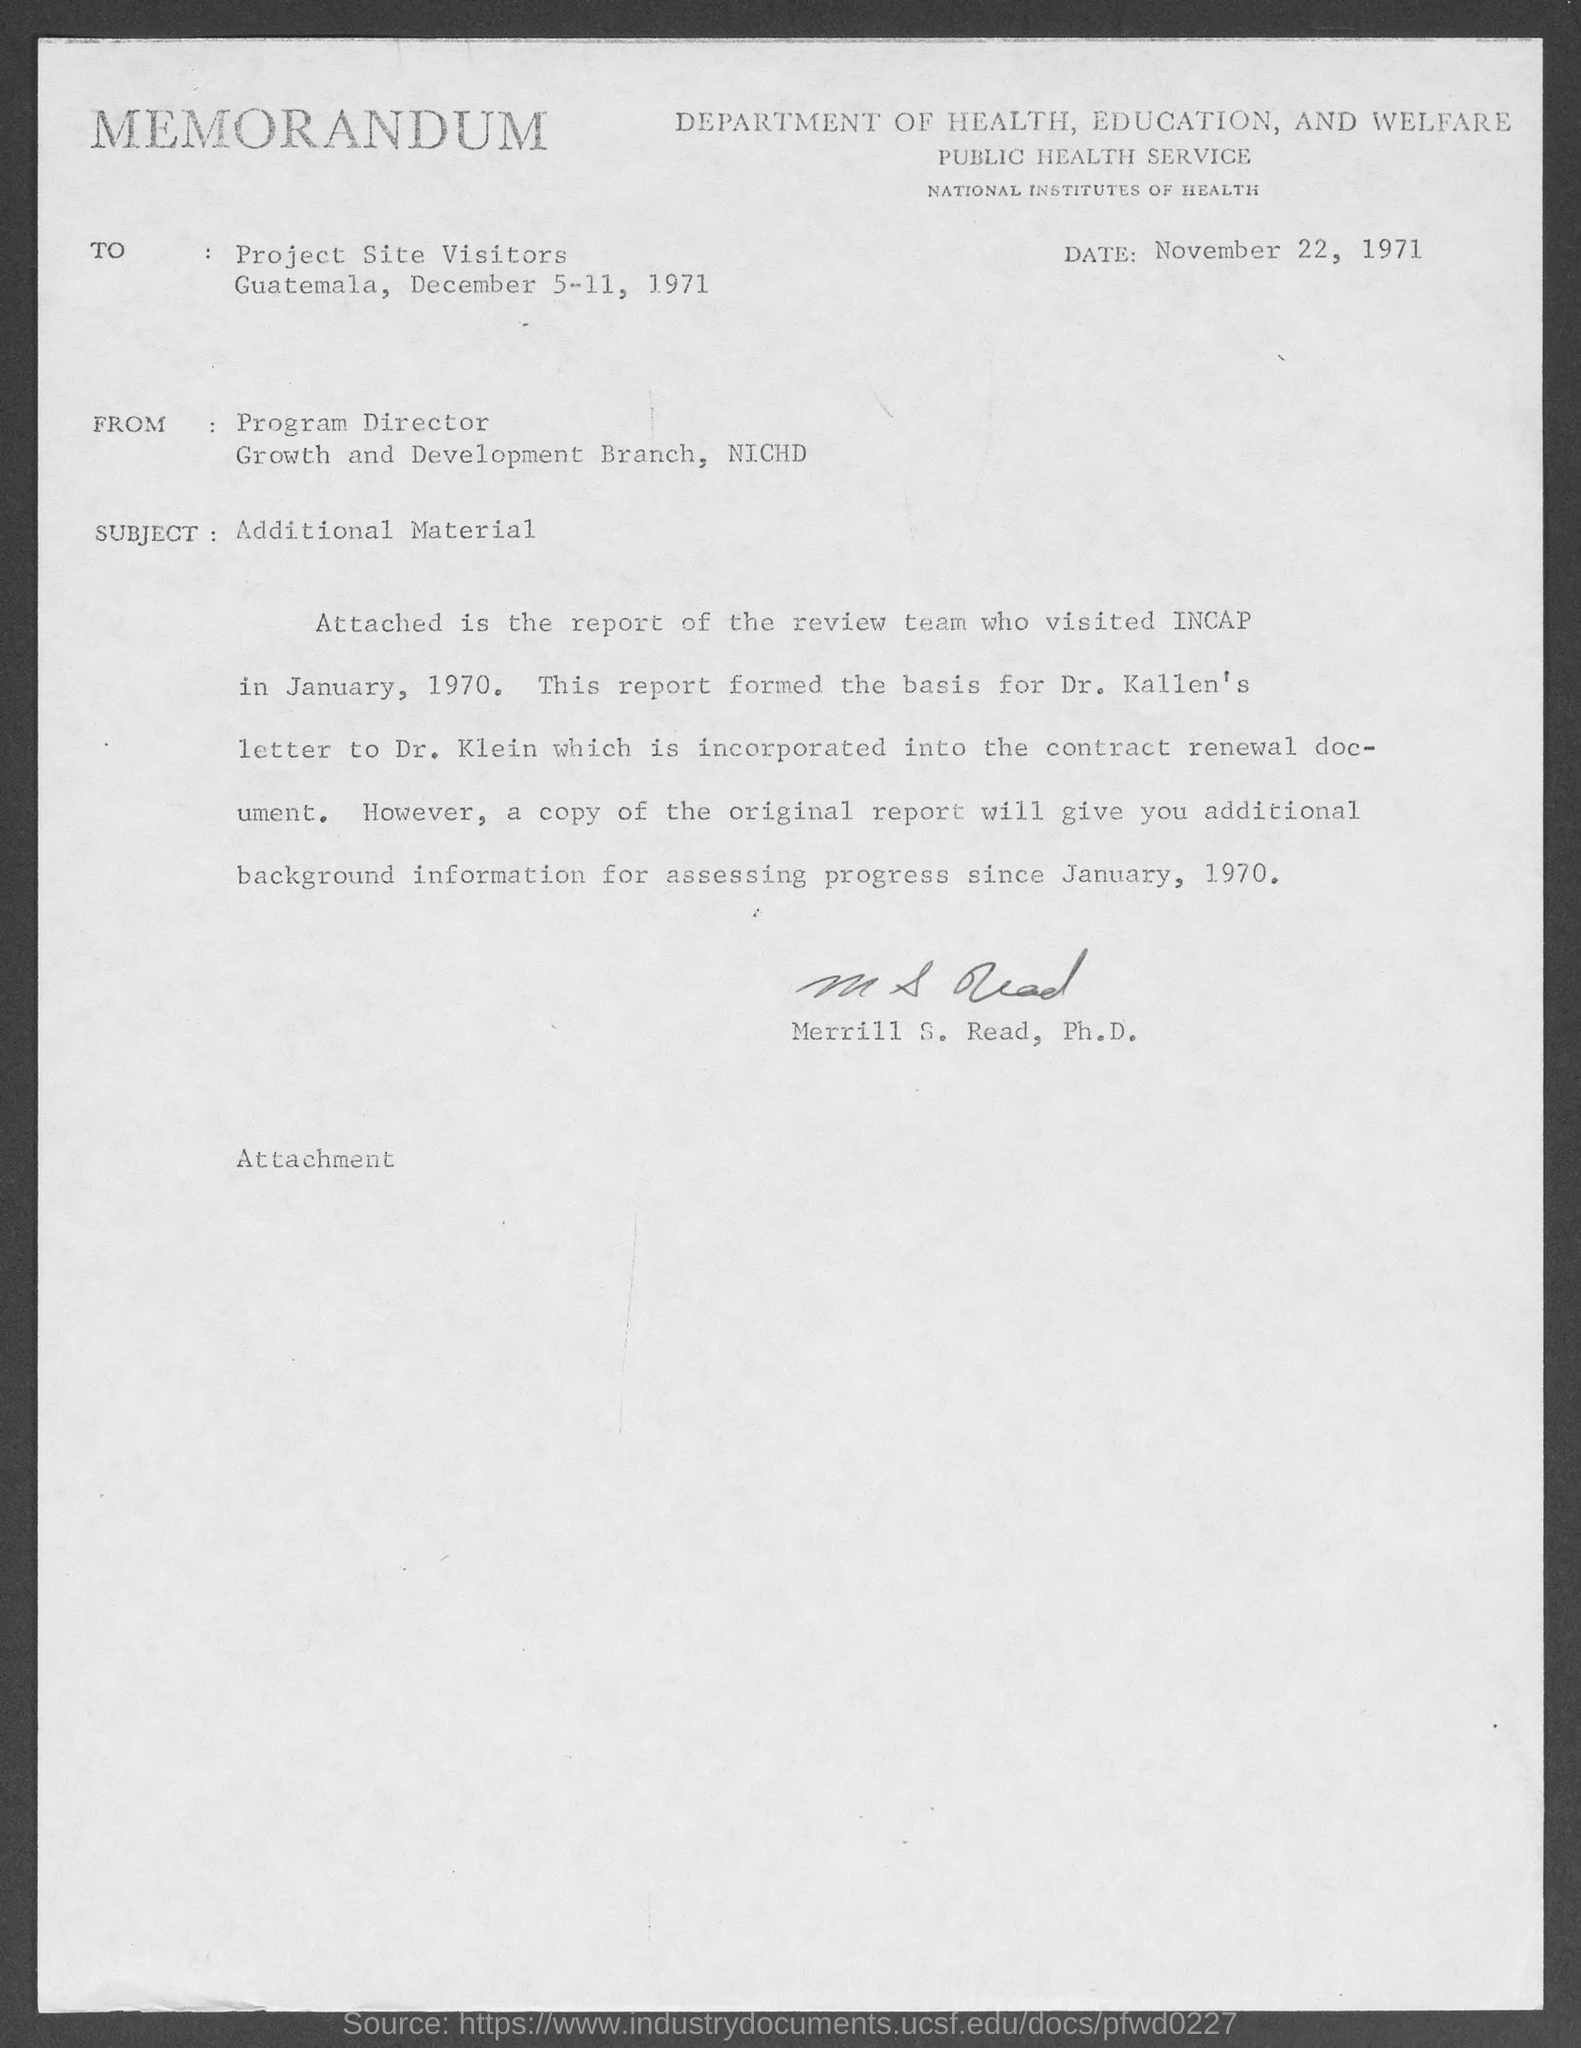What kind of communication is this?
Keep it short and to the point. MEMORANDUM. What is the date mentioned in the memorandum?
Your response must be concise. November 22, 1971. Who has signed this memorandum?
Provide a succinct answer. Merrill S. Read, Ph.D. What is the subject of this memorandum?
Offer a very short reply. Additional Material. To whom, the memorandum is addressed?
Offer a terse response. Project Site Visitors. 